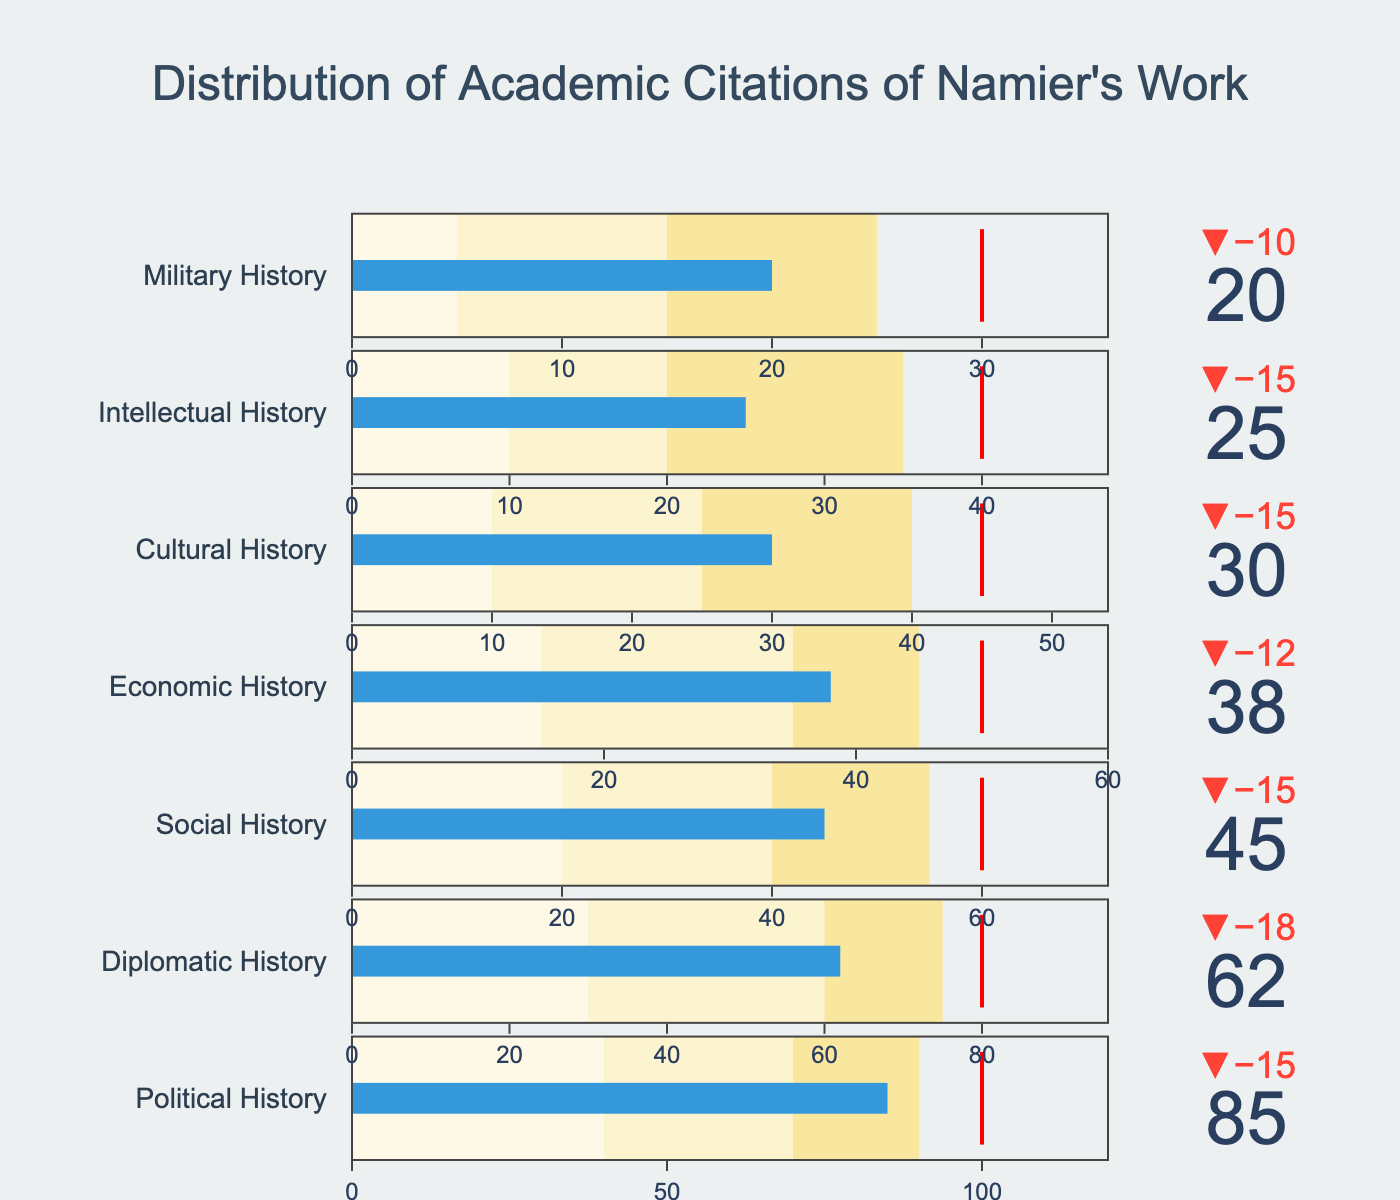How many historical sub-disciplines are listed in the chart? Count the number of different categories listed on the vertical axis of the chart.
Answer: 7 What is the maximum target value among all categories? Identify the highest "Target" value across all categories. The "Target" values are 100, 80, 60, 50, 45, 40, and 30. The highest is 100.
Answer: 100 Which sub-discipline has the smallest actual citation count and what is its value? Look for the category with the lowest "Actual" value. The lowest "Actual" value is for Military History at 20.
Answer: Military History, 20 What is the difference between the target and actual citations for Political History? Subtract the "Actual" value from the "Target" value for Political History: 100 - 85 = 15.
Answer: 15 Is the actual citation count for Social History above or below its target? Compare the "Actual" value (45) with the "Target" value (60) for Social History. 45 is below 60.
Answer: Below How many categories meet or exceed their historical range 2 citations? Check the "Actual" value against the "Range2" value for each category. Political History (85 > 70), Diplomatic History (62 > 60), and Social History (45 > 40). Three categories meet this condition.
Answer: 3 Which category's actual citations are closest to their target? Calculate the absolute difference between the "Actual" and "Target" values for each category. Political History (15), Diplomatic History (18), Social History (15), Economic History (12), Cultural History (15), Intellectual History (15), Military History (10). Military History has the smallest difference of 10.
Answer: Military History What is the color of the steps for the ranges in the bullet chart? The three ranges are colored in hues of yellow. They range from light yellow (#fef9e7), medium yellow (#fcf3cf), to dark yellow (#f9e79f).
Answer: Yellow tones Which categories have their actual citation counts within the range 1 boundary? Compare the "Actual" values to the respective "Range1" values to see if they fall within the first range: None of the categories have actual values within the first range since all "Actual" values are above their respective range 1 values.
Answer: None 